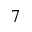Convert formula to latex. <formula><loc_0><loc_0><loc_500><loc_500>^ { 7 }</formula> 